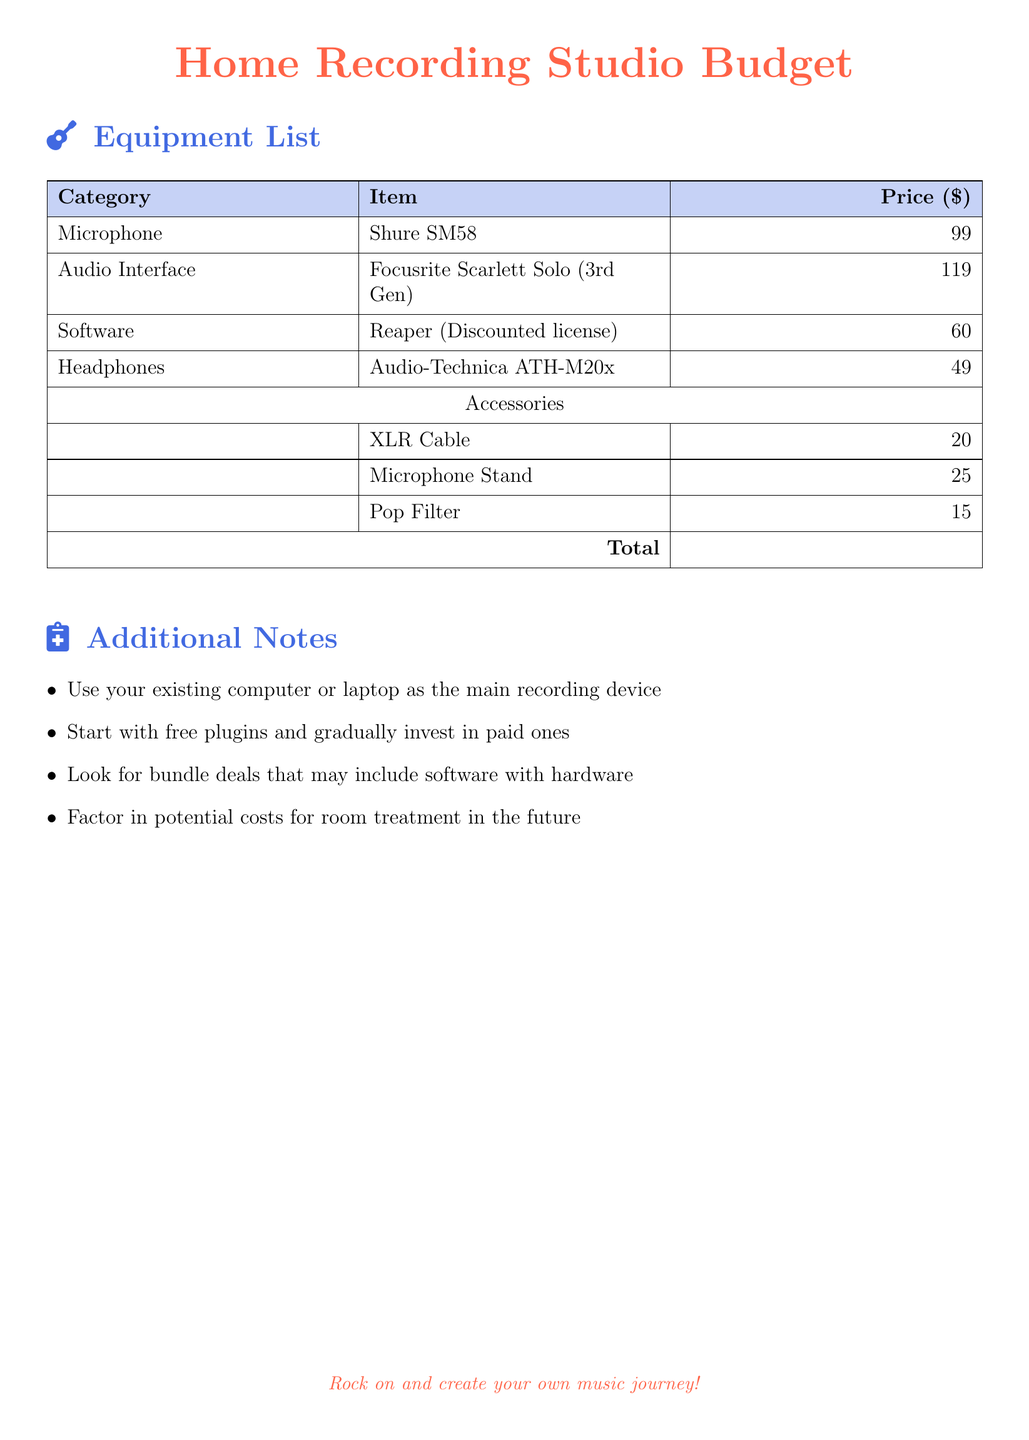What is the price of the Shure SM58? The price of the Shure SM58 microphone is listed in the equipment list.
Answer: 99 What is the total cost for the recording studio setup? The total cost is the sum of all items listed in the equipment list.
Answer: 387 What type of audio interface is recommended? The specific model of the audio interface is mentioned in the document.
Answer: Focusrite Scarlett Solo (3rd Gen) How much does the Reaper software cost? The cost of the Reaper software is specified in the equipment list.
Answer: 60 What accessory costs $20? The specific accessory with that price is listed under Accessories.
Answer: XLR Cable How many items are included in the equipment list? The document outlines the number of items in the equipment list.
Answer: 7 What is one suggestion for software when starting? This suggestion is mentioned in the additional notes.
Answer: Free plugins What is the price of the Audio-Technica ATH-M20x? The price for the Audio-Technica ATH-M20x headphones is included in the document.
Answer: 49 What type of document is this? The overall purpose of the document indicated at the top.
Answer: Budget 